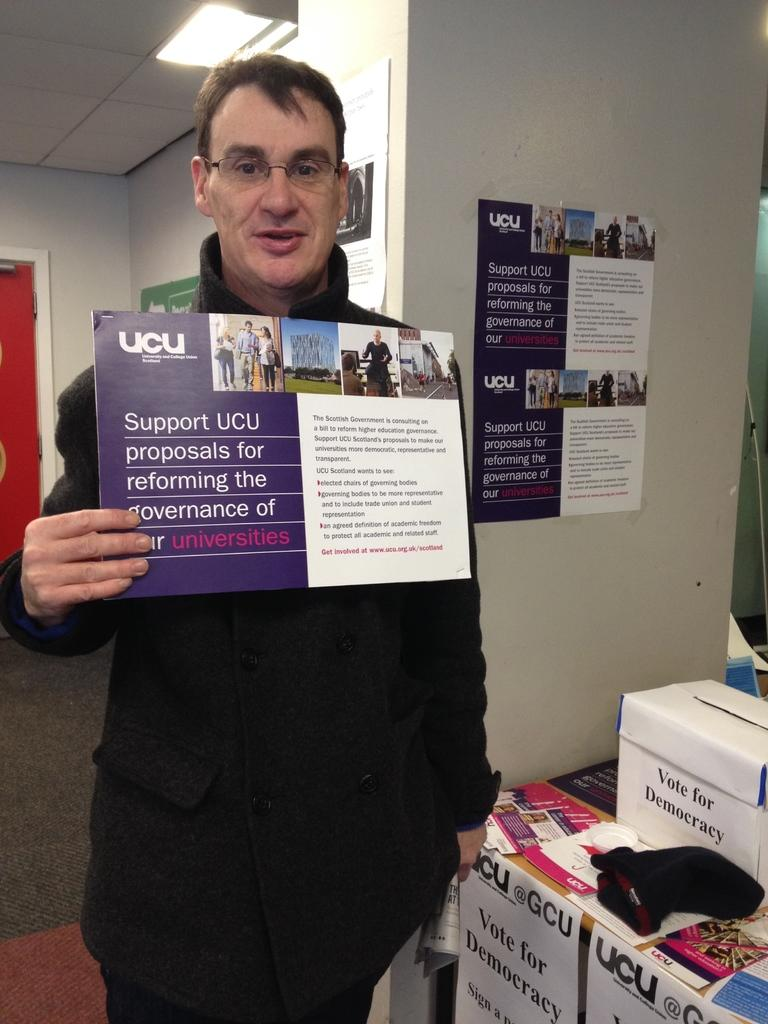<image>
Present a compact description of the photo's key features. A man holds a sign that says Support UCU 